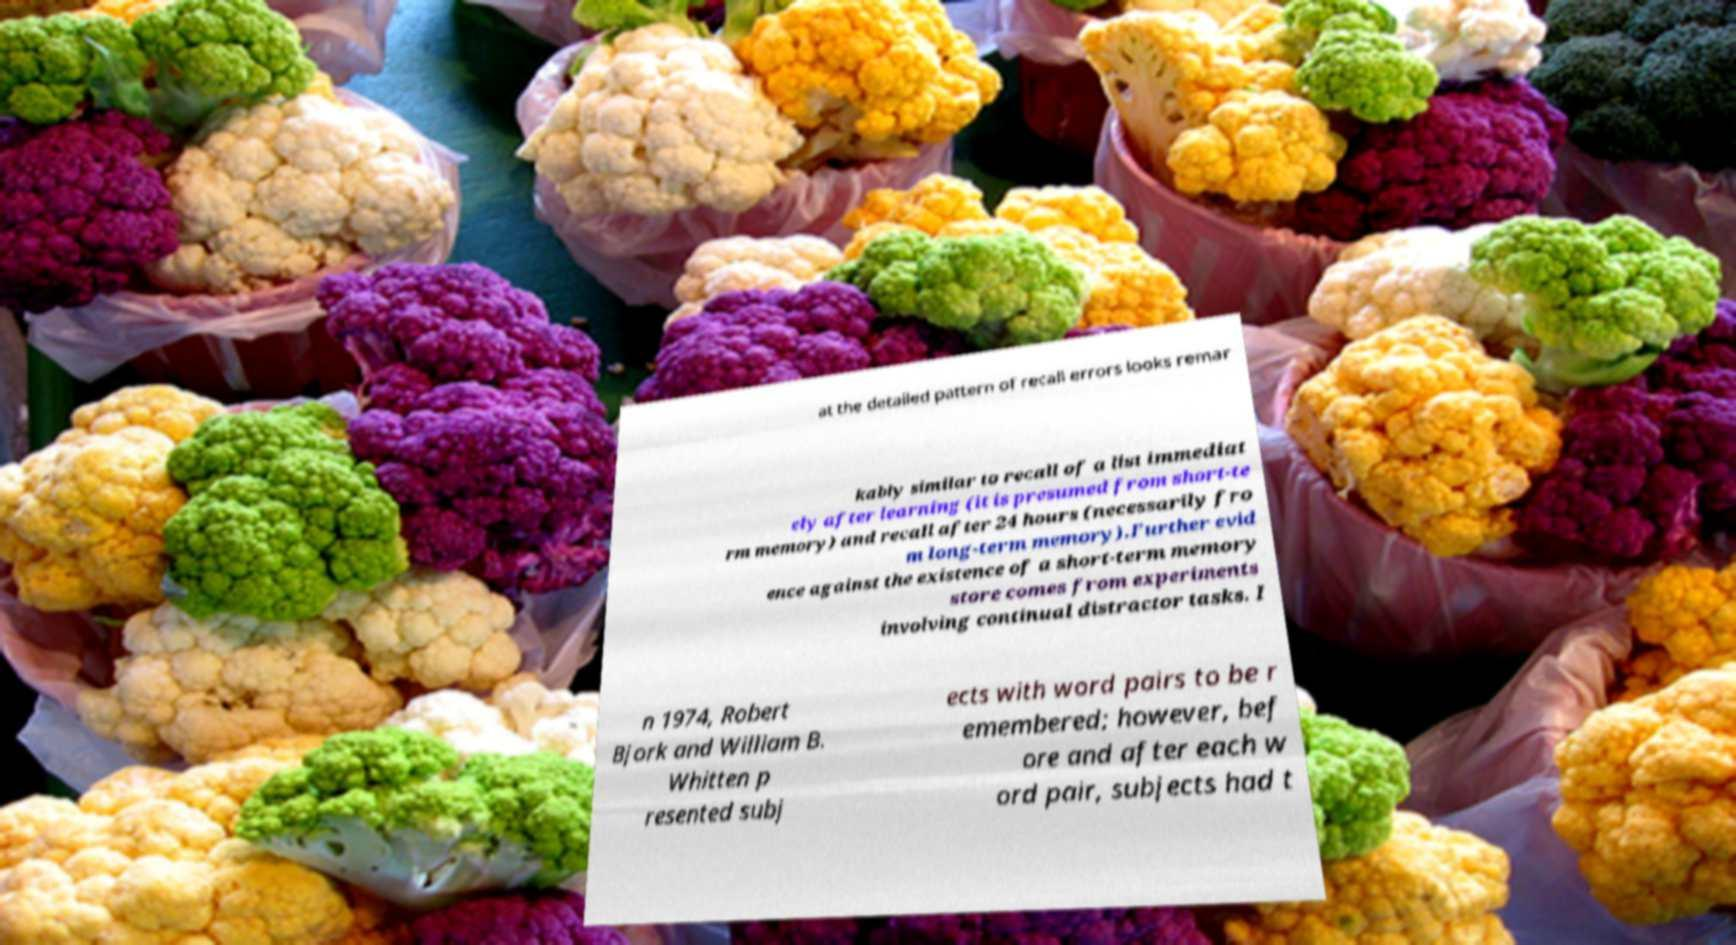I need the written content from this picture converted into text. Can you do that? at the detailed pattern of recall errors looks remar kably similar to recall of a list immediat ely after learning (it is presumed from short-te rm memory) and recall after 24 hours (necessarily fro m long-term memory).Further evid ence against the existence of a short-term memory store comes from experiments involving continual distractor tasks. I n 1974, Robert Bjork and William B. Whitten p resented subj ects with word pairs to be r emembered; however, bef ore and after each w ord pair, subjects had t 